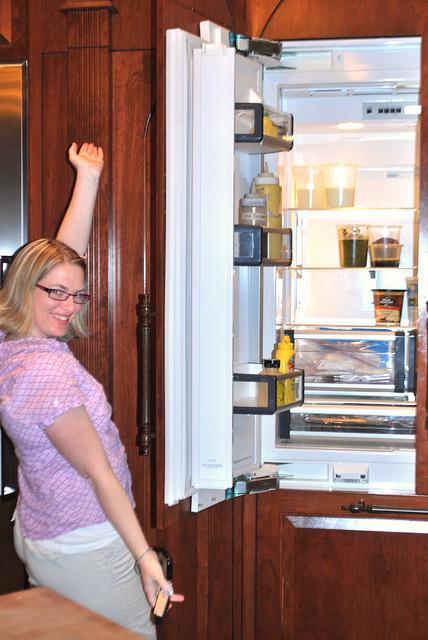Is the girl happy?
Short answer required. Yes. What did she open?
Be succinct. Refrigerator. Is the woman funny?
Answer briefly. Yes. What color is this woman's shirt?
Quick response, please. Pink. 